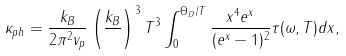Convert formula to latex. <formula><loc_0><loc_0><loc_500><loc_500>\kappa _ { p h } = \frac { k _ { B } } { 2 \pi ^ { 2 } v _ { p } } \left ( \frac { k _ { B } } { } \right ) ^ { 3 } T ^ { 3 } \int _ { 0 } ^ { \Theta _ { D } / T } \frac { x ^ { 4 } e ^ { x } } { ( e ^ { x } - 1 ) ^ { 2 } } \tau ( \omega , T ) d x ,</formula> 